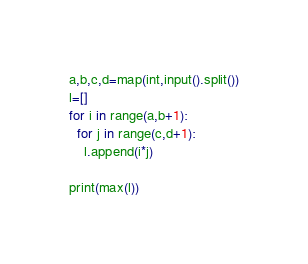<code> <loc_0><loc_0><loc_500><loc_500><_Python_>a,b,c,d=map(int,input().split())
l=[]
for i in range(a,b+1):
  for j in range(c,d+1):
    l.append(i*j)
    
print(max(l))</code> 